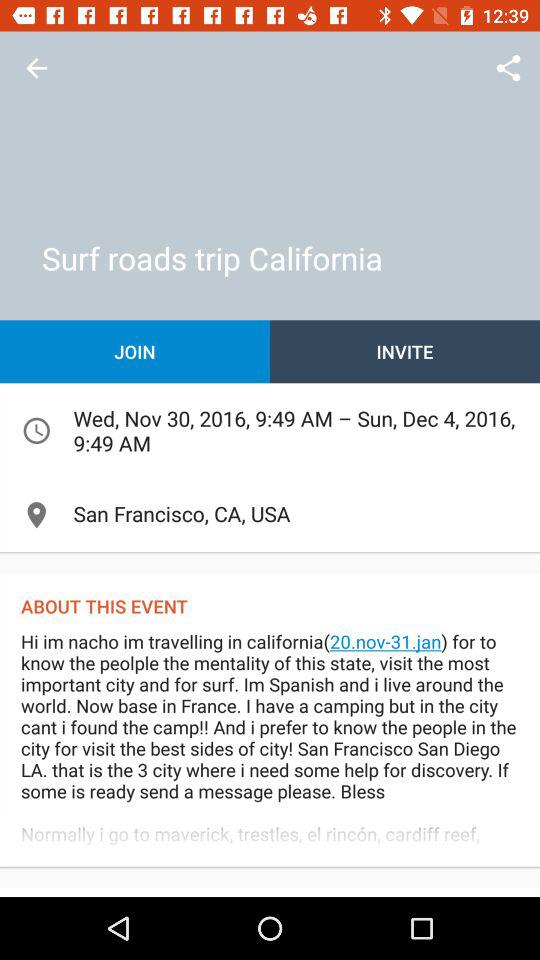How many cities are mentioned in the event description?
Answer the question using a single word or phrase. 3 